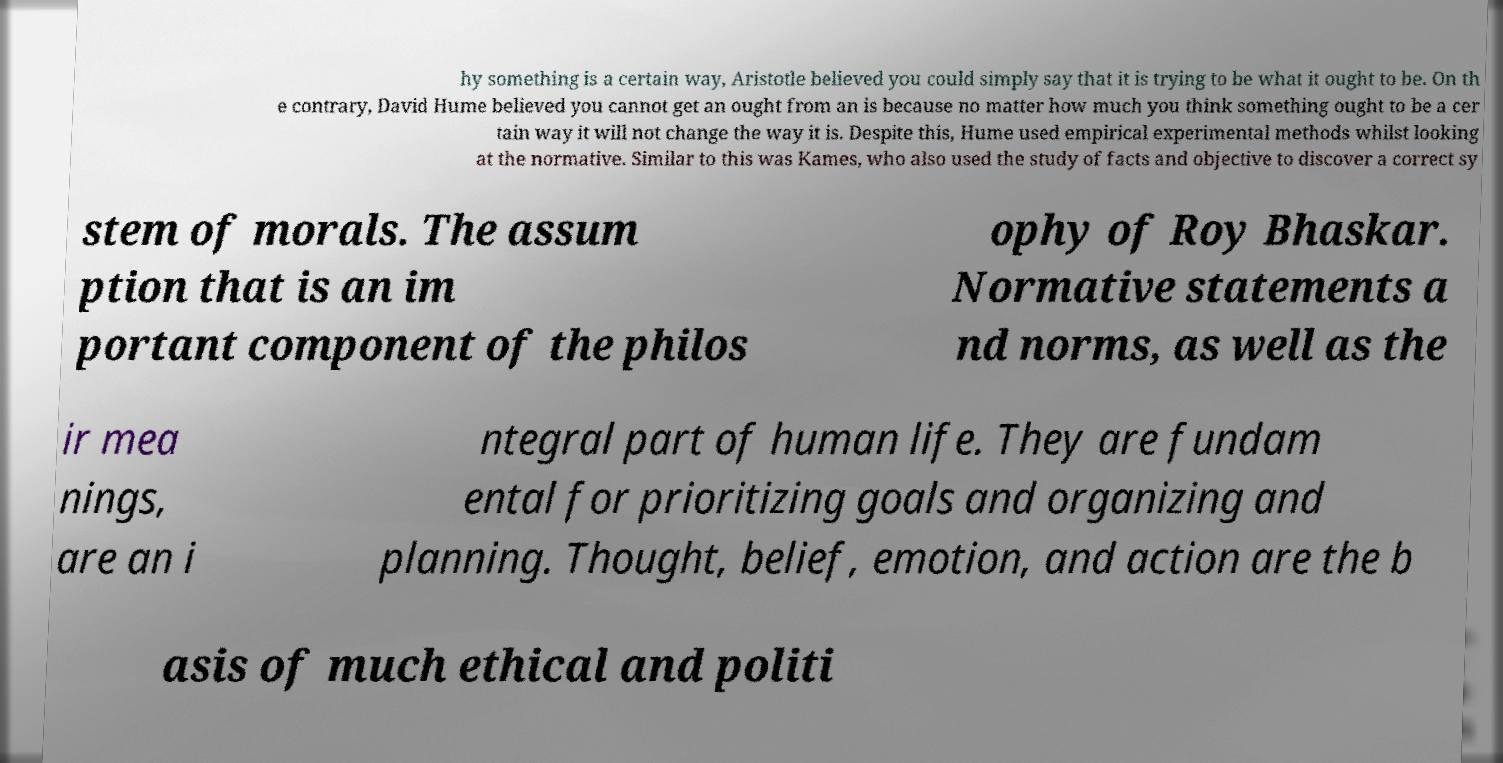I need the written content from this picture converted into text. Can you do that? hy something is a certain way, Aristotle believed you could simply say that it is trying to be what it ought to be. On th e contrary, David Hume believed you cannot get an ought from an is because no matter how much you think something ought to be a cer tain way it will not change the way it is. Despite this, Hume used empirical experimental methods whilst looking at the normative. Similar to this was Kames, who also used the study of facts and objective to discover a correct sy stem of morals. The assum ption that is an im portant component of the philos ophy of Roy Bhaskar. Normative statements a nd norms, as well as the ir mea nings, are an i ntegral part of human life. They are fundam ental for prioritizing goals and organizing and planning. Thought, belief, emotion, and action are the b asis of much ethical and politi 